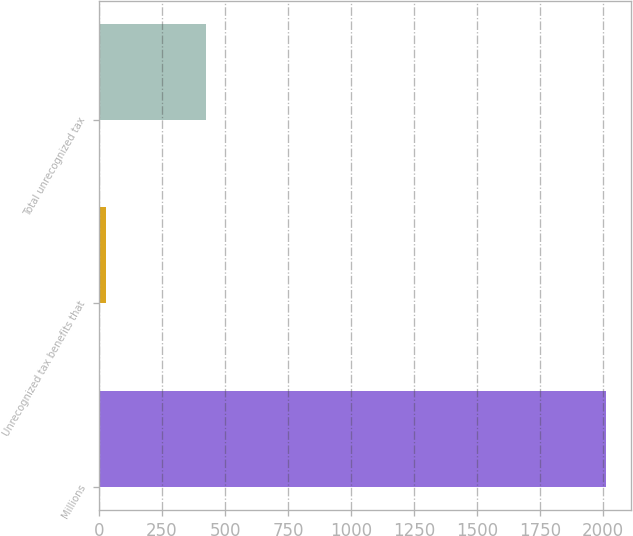Convert chart. <chart><loc_0><loc_0><loc_500><loc_500><bar_chart><fcel>Millions<fcel>Unrecognized tax benefits that<fcel>Total unrecognized tax<nl><fcel>2011<fcel>27<fcel>423.8<nl></chart> 